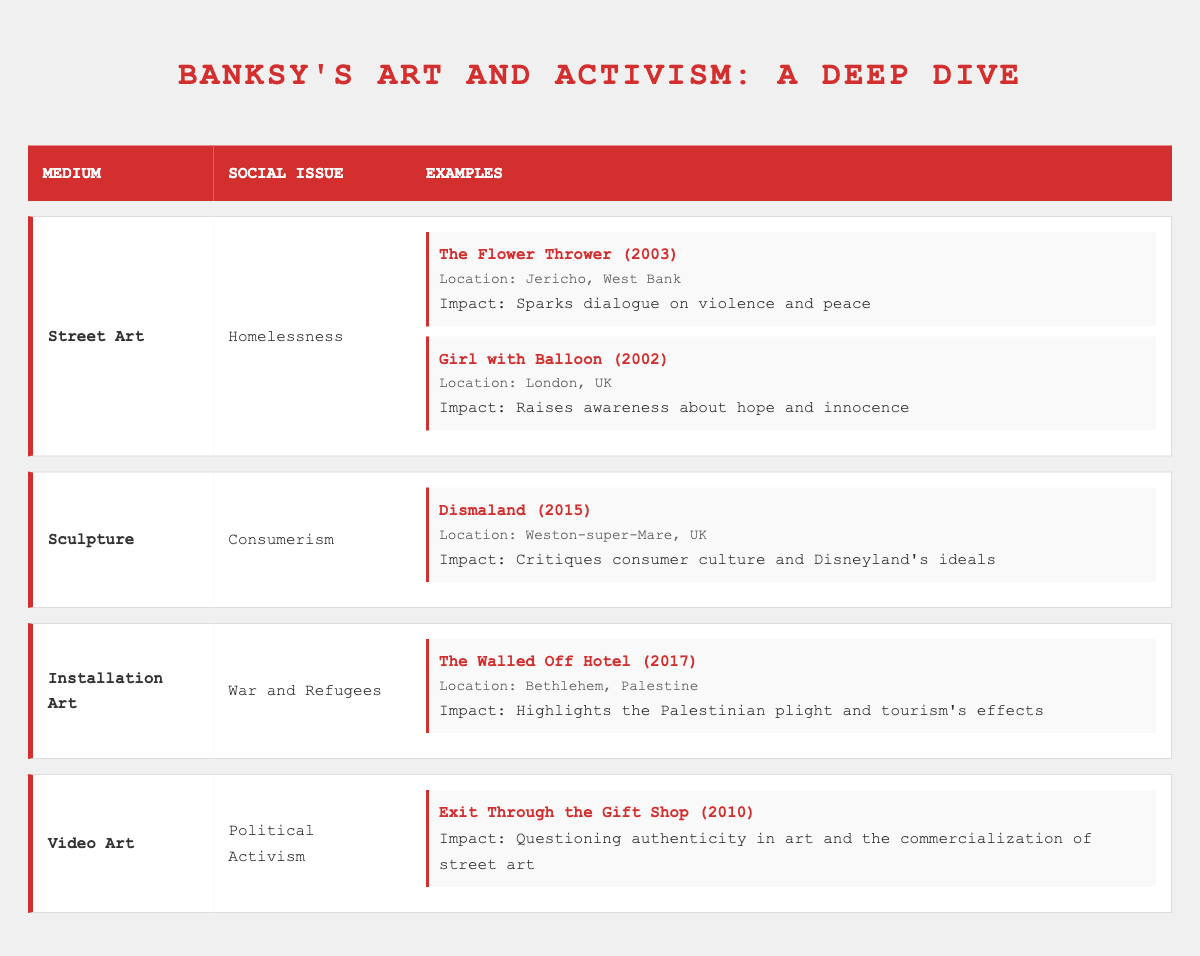What mediums did Banksy use to address homelessness? According to the table, Banksy addressed homelessness using the medium of Street Art.
Answer: Street Art What is the impact of "Girl with Balloon"? The table states that "Girl with Balloon" raises awareness about hope and innocence.
Answer: Raises awareness about hope and innocence How many examples of Street Art addressing social issues did Banksy create? The table shows two examples of Street Art: "The Flower Thrower" and "Girl with Balloon." Therefore, Banksy created 2 examples.
Answer: 2 examples Was "Dismaland" created to critique consumer culture? Yes, the table lists "Dismaland" under Sculpture with the social issue of Consumerism, indicating that it critiques consumer culture.
Answer: Yes What is the relationship between the medium of Video Art and the social issue it addresses? The table shows that the Video Art medium is linked to Political Activism, specifically through the example "Exit Through the Gift Shop," which questions the authenticity in art and the commercialization of street art.
Answer: Political Activism Which medium has more examples: Street Art or Installation Art? The table indicates that Street Art has 2 examples while Installation Art has only 1 example. Therefore, Street Art has more examples than Installation Art.
Answer: Street Art has more examples What social issue is addressed by "The Walled Off Hotel"? The table lists "The Walled Off Hotel" under Installation Art, addressing the social issue of War and Refugees.
Answer: War and Refugees In what year was "Exit Through the Gift Shop" released? From the table, "Exit Through the Gift Shop" was released in 2010, as indicated in the Video Art section.
Answer: 2010 Which social issue addressed by Banksy has the most examples? Looking at the table, the social issue of Homelessness has 2 examples from Street Art, while Consumerism and War and Refugees have 1 example each. Thus, Homelessness has the most examples.
Answer: Homelessness has the most examples 